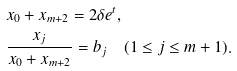Convert formula to latex. <formula><loc_0><loc_0><loc_500><loc_500>& x _ { 0 } + x _ { m + 2 } = 2 \delta e ^ { t } , \\ & \frac { x _ { j } } { x _ { 0 } + x _ { m + 2 } } = b _ { j } \quad ( 1 \leq j \leq m + 1 ) .</formula> 